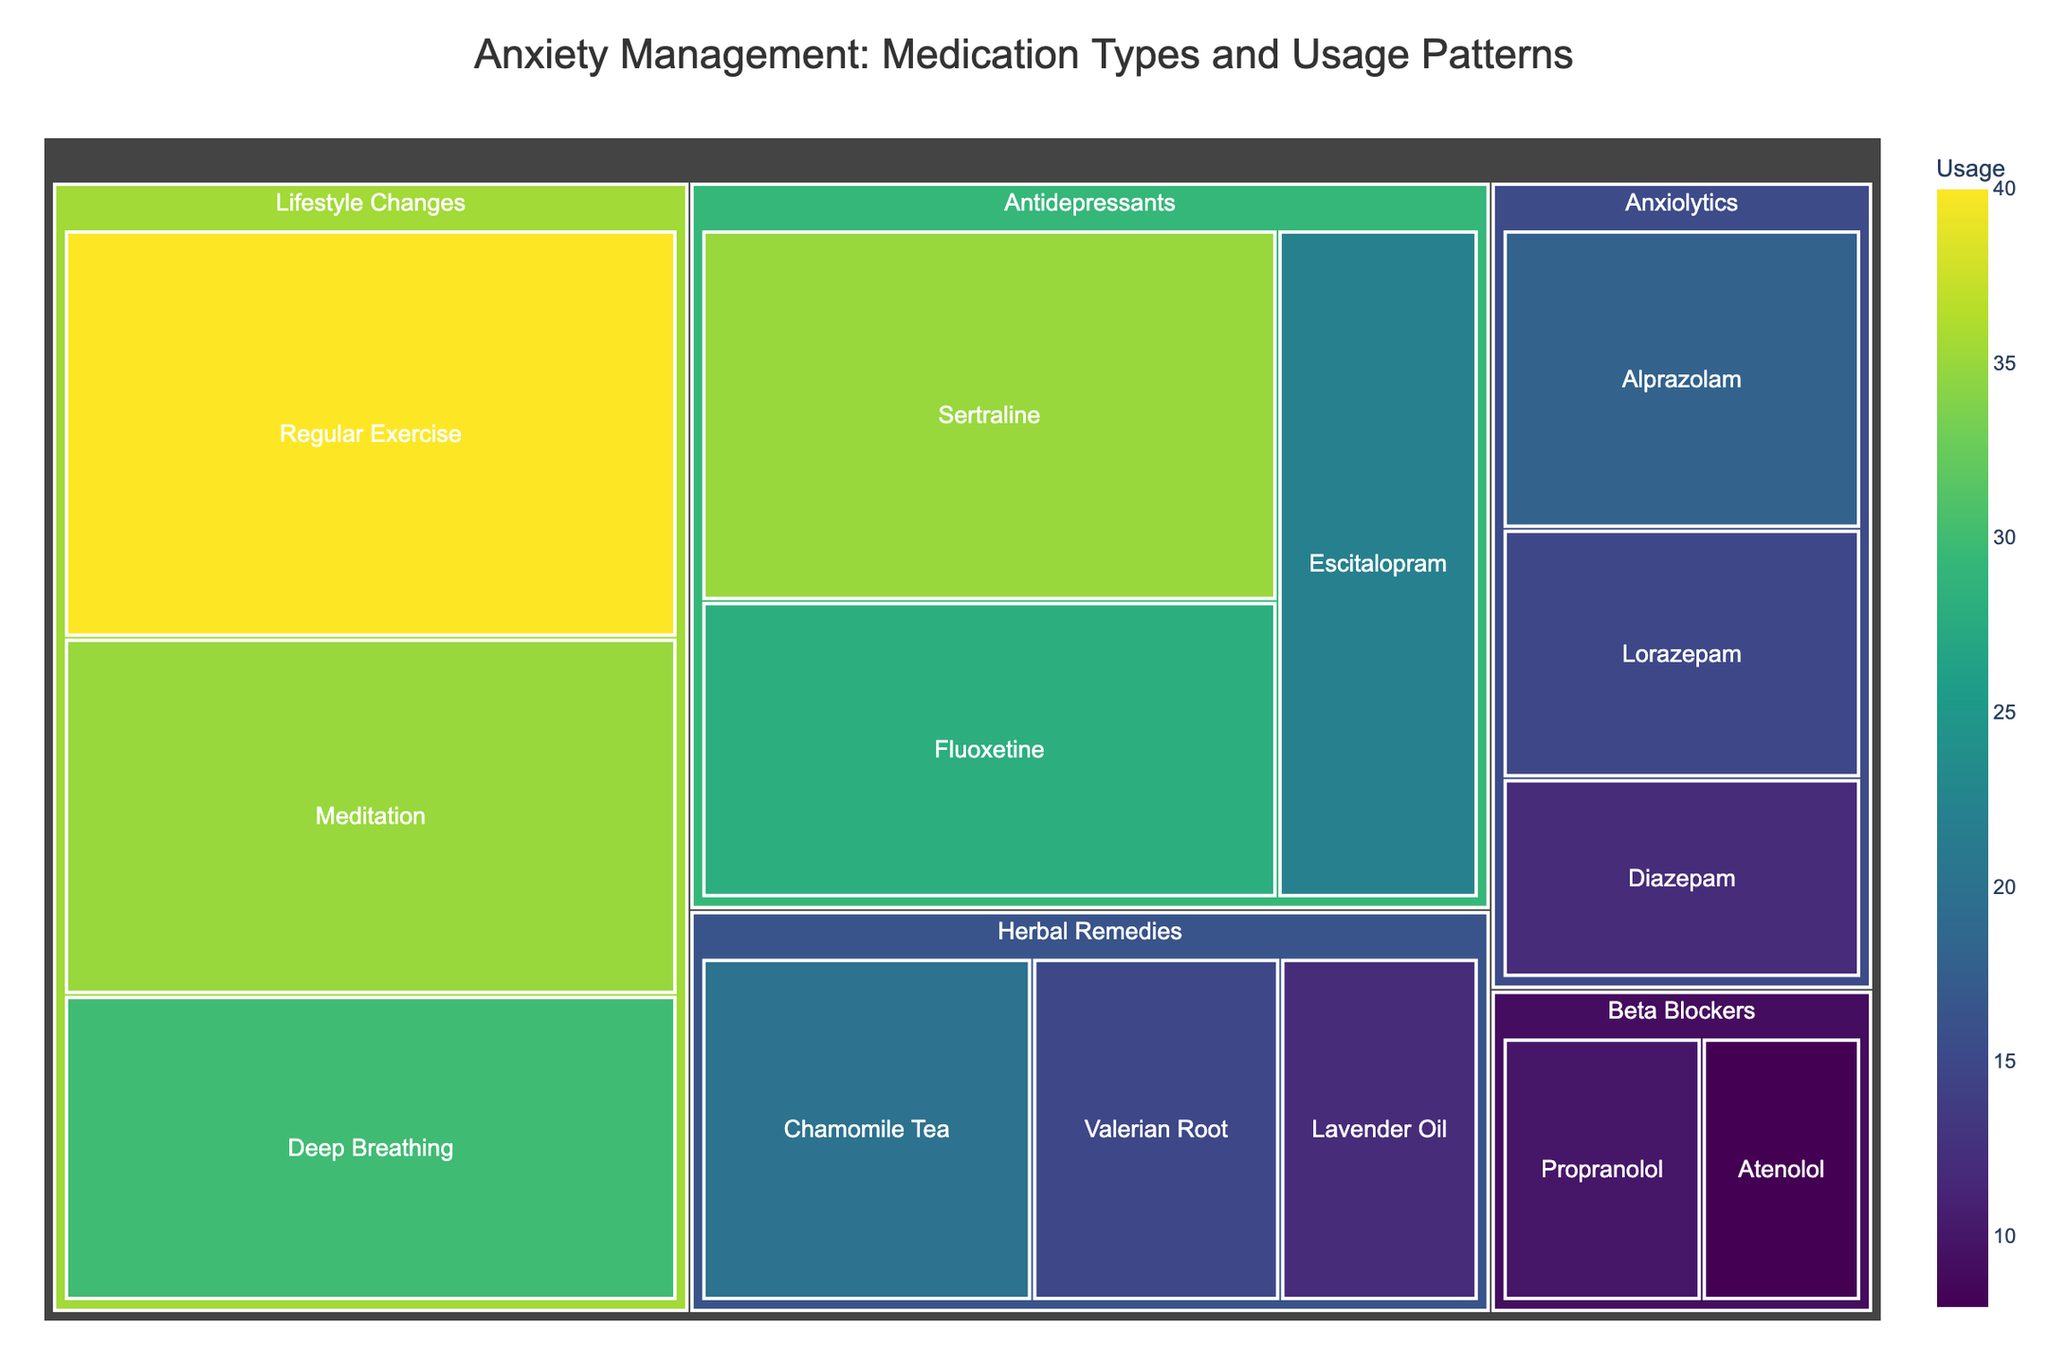What's the title of the figure? The title is usually positioned at the top of the figure for easy identification. In this case, it is "Anxiety Management: Medication Types and Usage Patterns".
Answer: Anxiety Management: Medication Types and Usage Patterns How many categories of medications and treatments are represented in the treemap? By visually inspecting the treemap, you can count the different overarching categories shown. These are Antidepressants, Anxiolytics, Beta Blockers, Herbal Remedies, and Lifestyle Changes.
Answer: 5 Which category has the highest usage value for a single medication? To find this, look for the largest box representing a single medication or treatment under each category. The largest box is for "Regular Exercise" under "Lifestyle Changes" with a value of 40.
Answer: Lifestyle Changes What is the combined usage of all Anxiolytics medications? You need to find the usage values for all medications under the Anxiolytics category and sum them up: Alprazolam (18), Lorazepam (15), and Diazepam (12). The combined usage is 18 + 15 + 12 = 45.
Answer: 45 Which medication has a higher usage: Sertraline or Escitalopram? Compare the values of Sertraline and Escitalopram directly from the treemap. Sertraline has a usage of 35, while Escitalopram has a usage of 22.
Answer: Sertraline What is the average usage value of Herbal Remedies? Calculate the average usage for the medications under Herbal Remedies. The values are Chamomile Tea (20), Valerian Root (15), and Lavender Oil (12). The sum is 20 + 15 + 12 = 47, and the average is 47 / 3 ≈ 15.67.
Answer: 15.67 Is the usage of Propranolol higher or lower than Atenolol? Compare the usage values for Propranolol (10) and Atenolol (8). Propranolol has a higher usage.
Answer: Higher What is the combined usage for all medications in the Antidepressants category? Add up the usage values for Sertraline (35), Fluoxetine (28), and Escitalopram (22). The total is 35 + 28 + 22 = 85.
Answer: 85 What proportion of the total usage does Regular Exercise represent? Calculate the proportion by taking the value for Regular Exercise (40) and dividing it by the sum of usage values for all medications and treatments (total sum). The total sum is 35+28+22+18+15+12+10+8+20+15+12+40+35+30 = 300. The proportion is 40 / 300 = 0.1333 or 13.33%.
Answer: 13.33% 